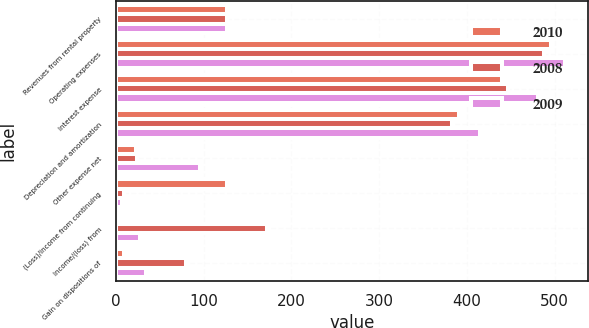<chart> <loc_0><loc_0><loc_500><loc_500><stacked_bar_chart><ecel><fcel>Revenues from rental property<fcel>Operating expenses<fcel>Interest expense<fcel>Depreciation and amortization<fcel>Other expense net<fcel>(Loss)/income from continuing<fcel>Income/(loss) from<fcel>Gain on dispositions of<nl><fcel>2010<fcel>126.4<fcel>495.6<fcel>440.6<fcel>390.8<fcel>22.9<fcel>126.4<fcel>1.2<fcel>8.8<nl><fcel>2008<fcel>126.4<fcel>488.2<fcel>447.2<fcel>383.5<fcel>24<fcel>8.5<fcel>172.6<fcel>79.9<nl><fcel>2009<fcel>126.4<fcel>512.1<fcel>481.2<fcel>415.4<fcel>95.2<fcel>6.8<fcel>27<fcel>33.9<nl></chart> 